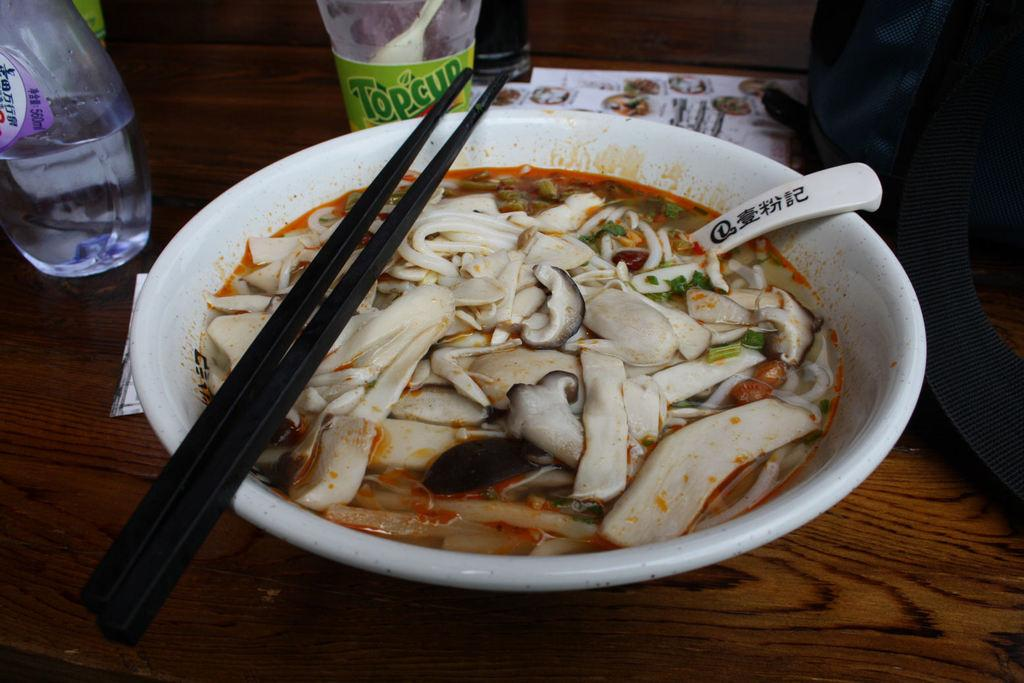Provide a one-sentence caption for the provided image. A noodle dish sits in front of a Topcup juice bottle. 